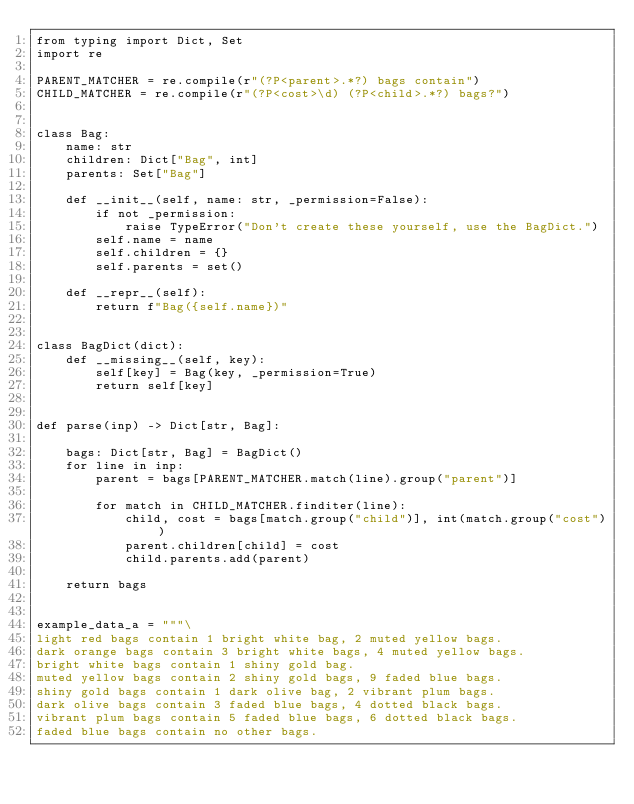<code> <loc_0><loc_0><loc_500><loc_500><_Python_>from typing import Dict, Set
import re

PARENT_MATCHER = re.compile(r"(?P<parent>.*?) bags contain")
CHILD_MATCHER = re.compile(r"(?P<cost>\d) (?P<child>.*?) bags?")


class Bag:
    name: str
    children: Dict["Bag", int]
    parents: Set["Bag"]

    def __init__(self, name: str, _permission=False):
        if not _permission:
            raise TypeError("Don't create these yourself, use the BagDict.")
        self.name = name
        self.children = {}
        self.parents = set()

    def __repr__(self):
        return f"Bag({self.name})"


class BagDict(dict):
    def __missing__(self, key):
        self[key] = Bag(key, _permission=True)
        return self[key]


def parse(inp) -> Dict[str, Bag]:

    bags: Dict[str, Bag] = BagDict()
    for line in inp:
        parent = bags[PARENT_MATCHER.match(line).group("parent")]

        for match in CHILD_MATCHER.finditer(line):
            child, cost = bags[match.group("child")], int(match.group("cost"))
            parent.children[child] = cost
            child.parents.add(parent)

    return bags


example_data_a = """\
light red bags contain 1 bright white bag, 2 muted yellow bags.
dark orange bags contain 3 bright white bags, 4 muted yellow bags.
bright white bags contain 1 shiny gold bag.
muted yellow bags contain 2 shiny gold bags, 9 faded blue bags.
shiny gold bags contain 1 dark olive bag, 2 vibrant plum bags.
dark olive bags contain 3 faded blue bags, 4 dotted black bags.
vibrant plum bags contain 5 faded blue bags, 6 dotted black bags.
faded blue bags contain no other bags.</code> 